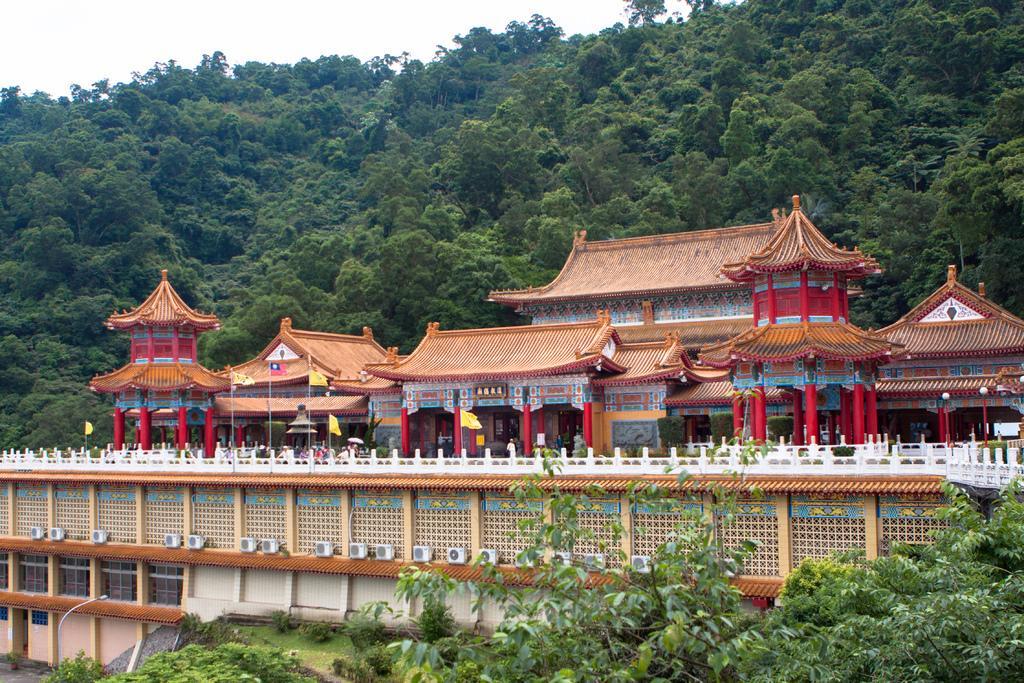Could you give a brief overview of what you see in this image? In the center of the image we can see persons, buildings and air conditioners. At the bottom of the image we can see trees and grass. In the background we can see trees, hill and sky. 